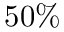<formula> <loc_0><loc_0><loc_500><loc_500>5 0 \%</formula> 